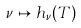Convert formula to latex. <formula><loc_0><loc_0><loc_500><loc_500>\nu \mapsto h _ { \nu } ( T )</formula> 